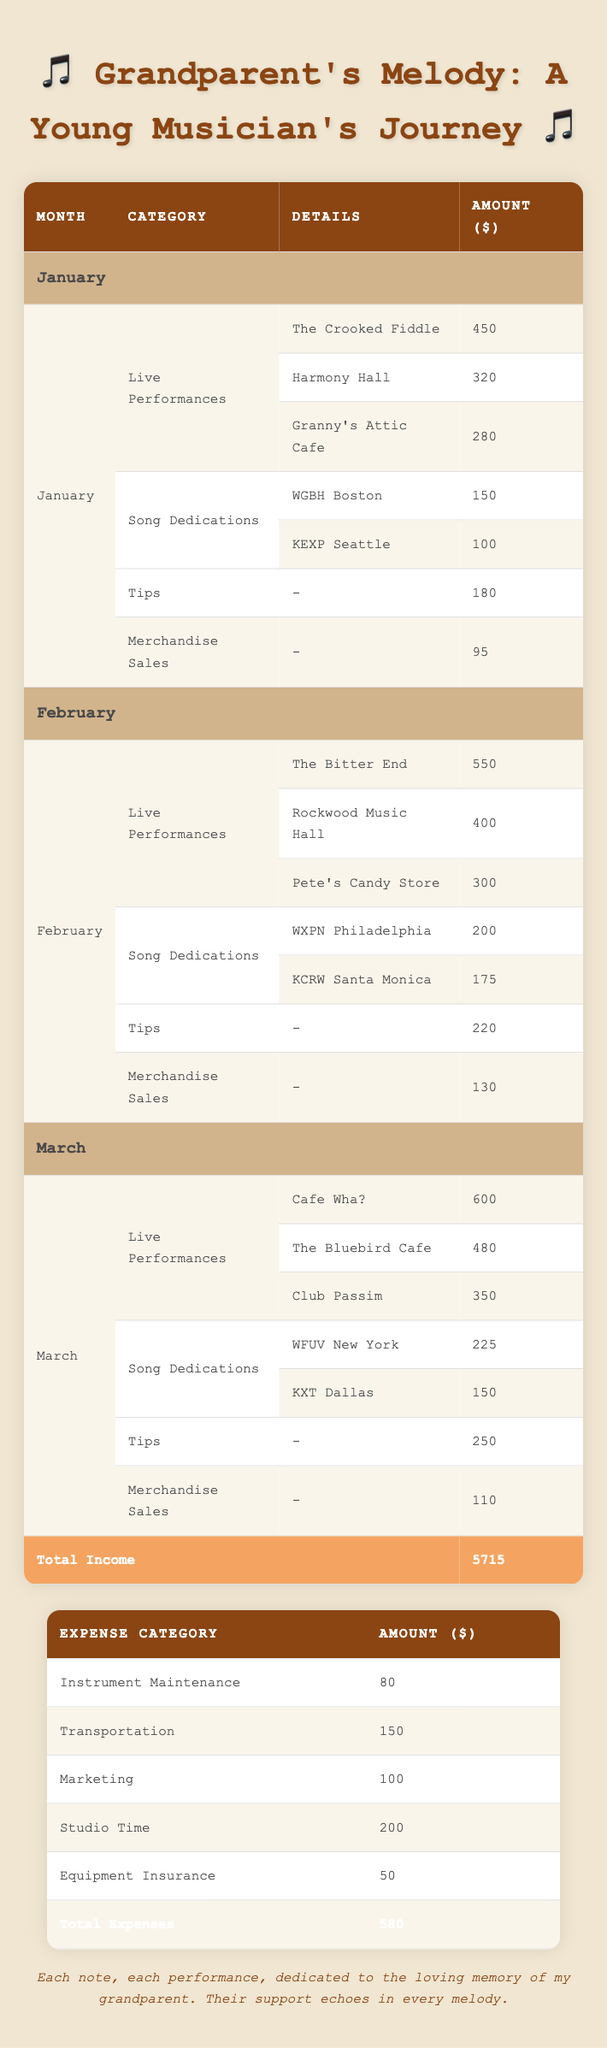What was the total income for January? To find the total income for January, I will look at all the earnings in that month: live performances (450 + 320 + 280), song dedications (150 + 100), tips (180), and merchandise sales (95). Adding these together gives me 450 + 320 + 280 + 150 + 100 + 180 + 95 = 1575.
Answer: 1575 Which venue earned the most money in February? I will check the live performances for February: The Bitter End (550), Rockwood Music Hall (400), and Pete's Candy Store (300). The highest earnings among these is 550 from The Bitter End.
Answer: The Bitter End Did the musician earn more from song dedications in March compared to February? For February, the total earnings from song dedications are 200 + 175 = 375. For March, the total is 225 + 150 = 375. Since both totals are equal at 375, the musician did not earn more in either month.
Answer: No What was the average tips earned per month over the three months? I will add the tips from each month: January (180), February (220), and March (250). The total tips earned are 180 + 220 + 250 = 650. To find the average, I divide this total by the number of months, which is 3: 650 / 3 = 216.67.
Answer: 216.67 What was the total expenses for the three months? The expense categories include Instrument Maintenance (80), Transportation (150), Marketing (100), Studio Time (200), and Equipment Insurance (50). I will sum these amounts: 80 + 150 + 100 + 200 + 50 = 580.
Answer: 580 In which month did the musician earn the highest tips? The tips for January are 180, for February are 220, and for March are 250. Comparing these values, March had the highest tips at 250.
Answer: March Was the total income in January greater than the total expenses? The total income for January is 1575 as calculated before, and the total expenses are 580. Since 1575 is greater than 580, the answer is yes.
Answer: Yes How much did the musician earn from taxes compared to merchandise sales in March? The musician did not earn anything attributed to taxes in the table, while merchandise sales in March were 110. Thus, the comparison shows 0 in taxes versus 110 in merchandise sales.
Answer: Merchandise sales were more 